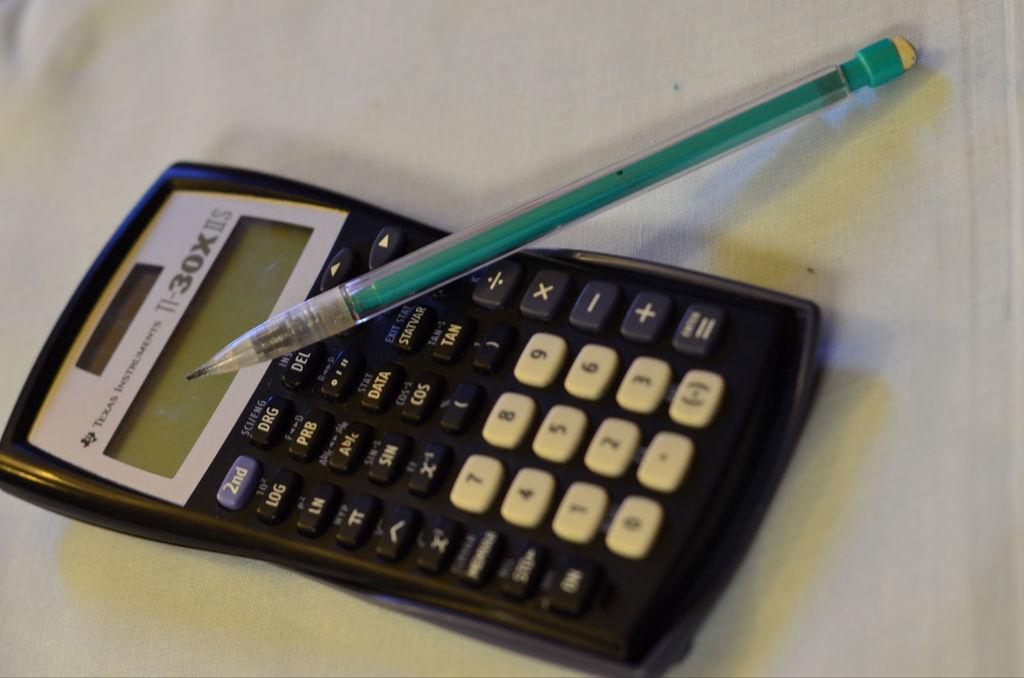Provide a one-sentence caption for the provided image. A TI-30x calculator with a pencil on top of it. 